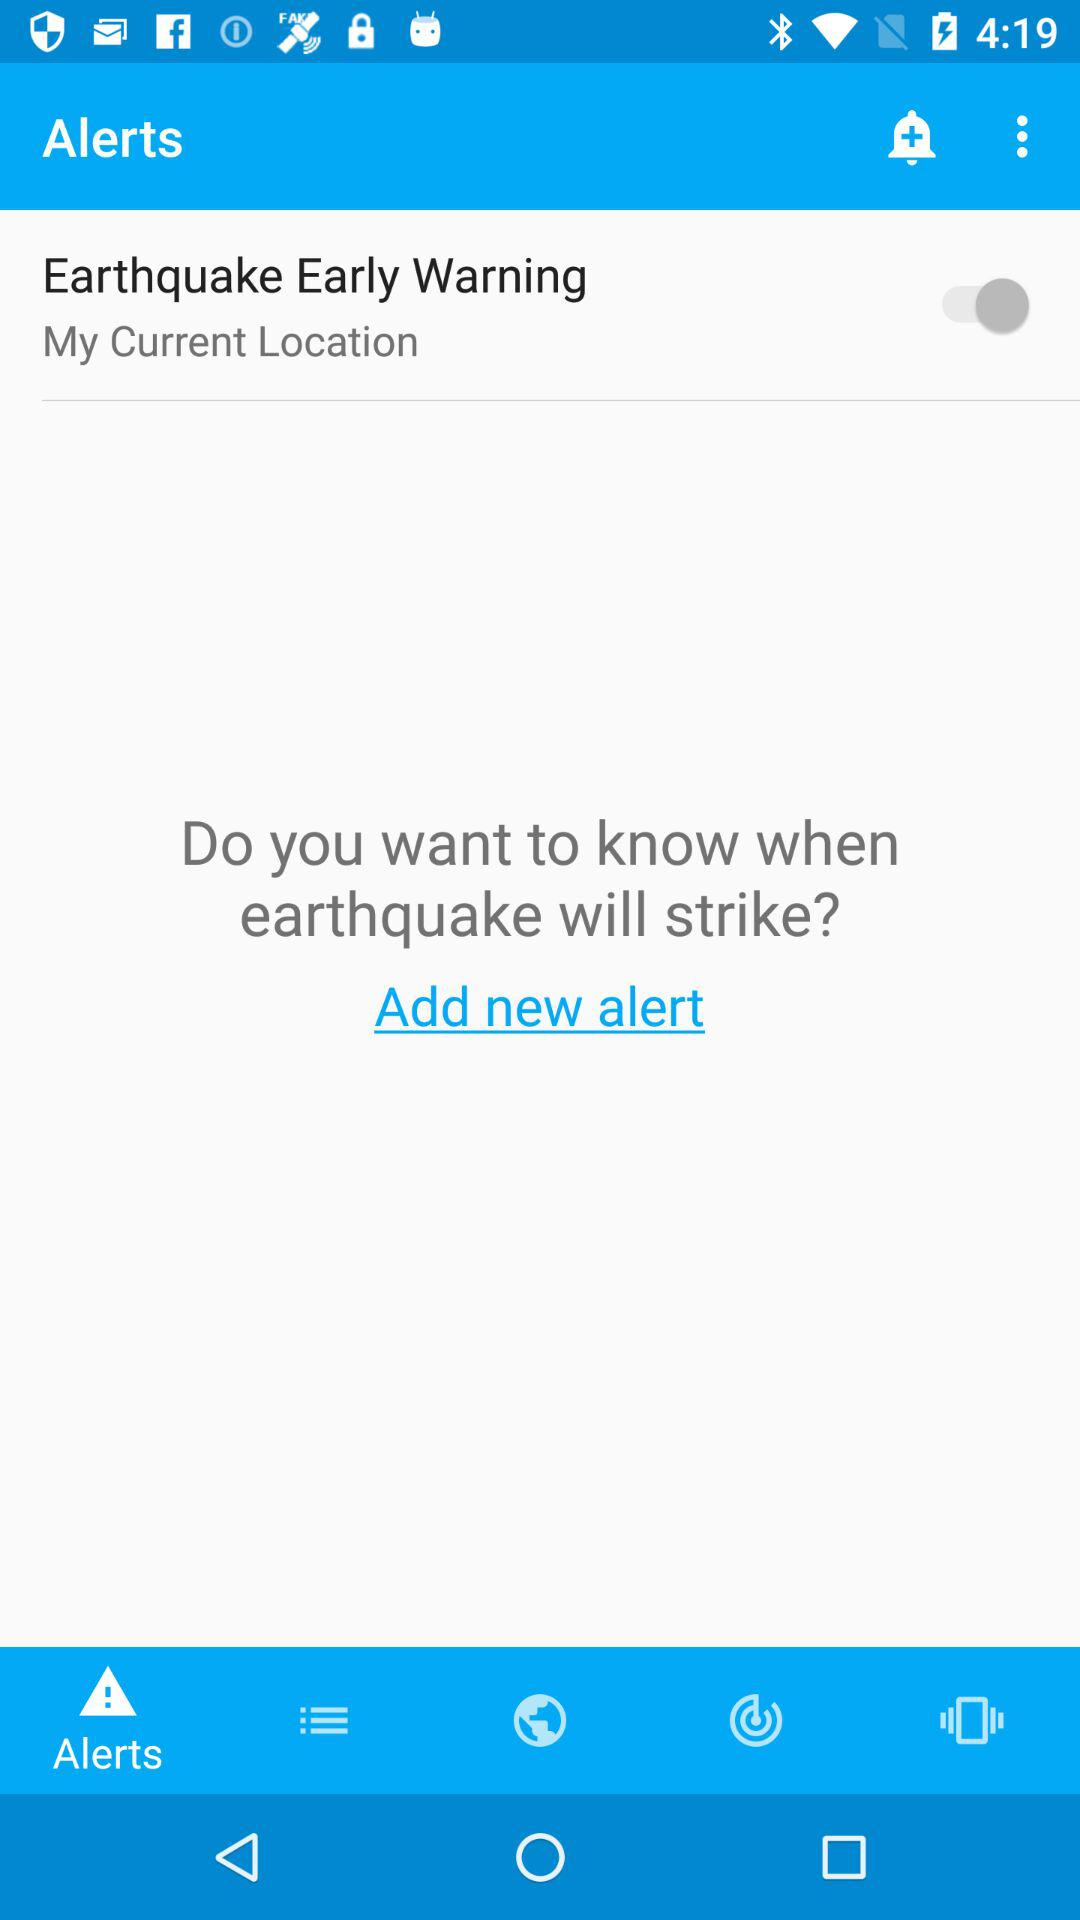What is the version of this application?
When the provided information is insufficient, respond with <no answer>. <no answer> 